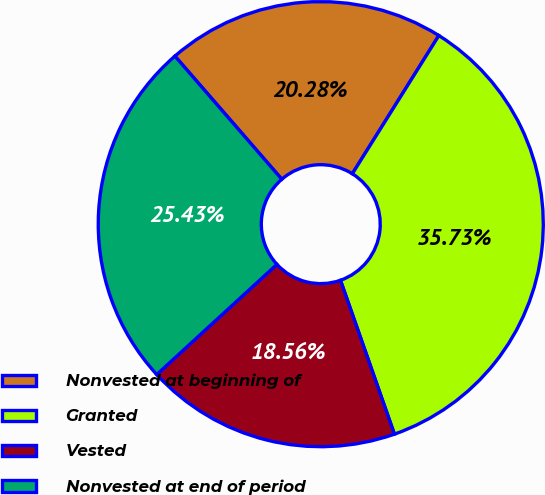<chart> <loc_0><loc_0><loc_500><loc_500><pie_chart><fcel>Nonvested at beginning of<fcel>Granted<fcel>Vested<fcel>Nonvested at end of period<nl><fcel>20.28%<fcel>35.73%<fcel>18.56%<fcel>25.43%<nl></chart> 